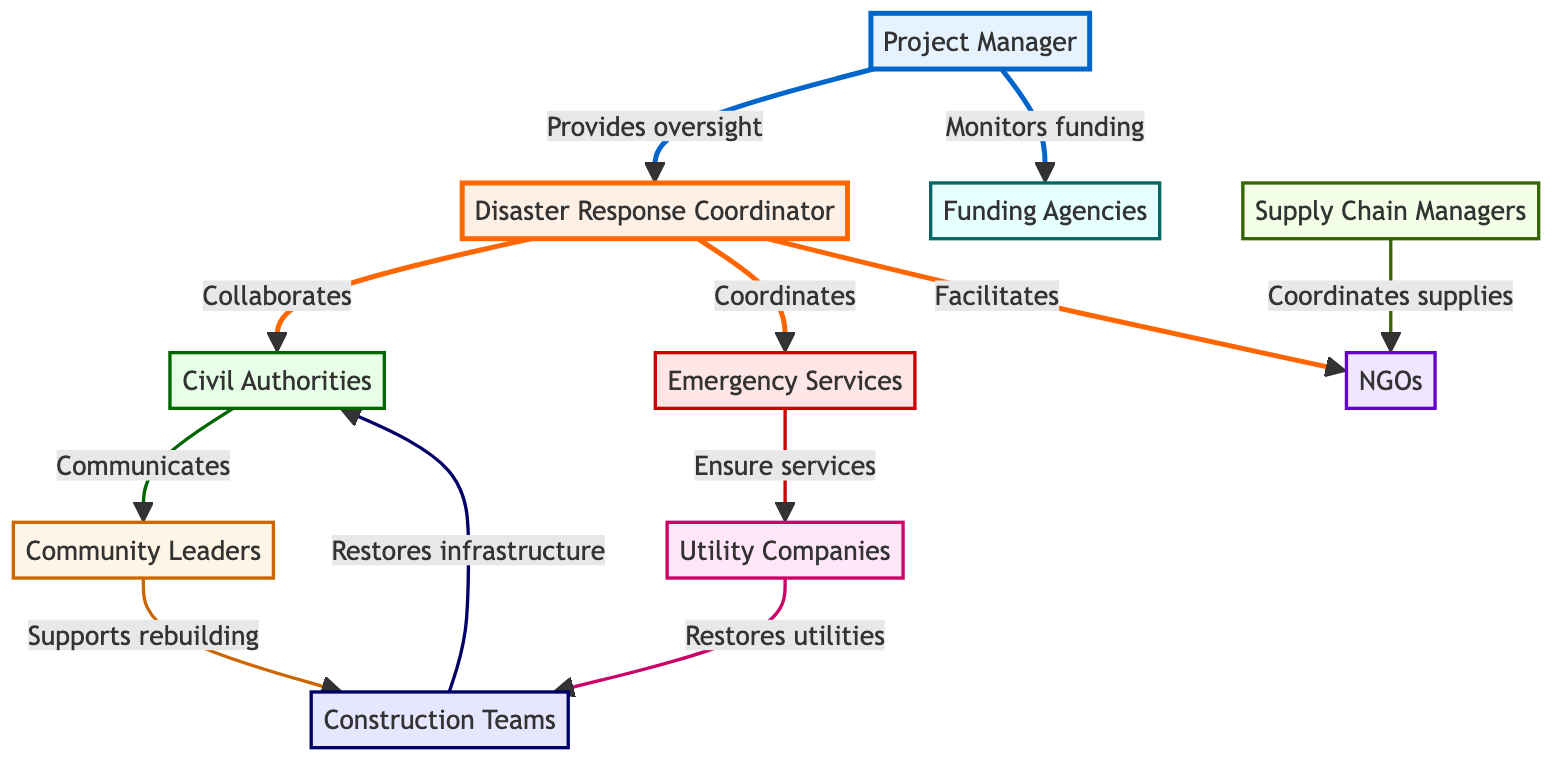What are the roles of the node with ID 4? The node with ID 4 is labeled "Emergency Services," which encompasses police, fire department, and medical teams providing immediate aid.
Answer: Emergency Services How many nodes are present in the diagram? The diagram contains a total of 10 nodes representing different stakeholders involved in post-disaster recovery.
Answer: 10 Who does the Disaster Response Coordinator coordinate with for immediate emergency response? The Disaster Response Coordinator, represented by node ID 2, coordinates with Emergency Services, represented by node ID 4, for immediate emergency response.
Answer: Emergency Services What is the relationship between the Project Manager and Funding Agencies? The Project Manager provides monitoring and reporting on funding utilization for the Funding Agencies in the diagram.
Answer: Monitors and reports on funding utilization Which node facilitates the involvement of Non-Governmental Organizations? The node that facilitates NGO involvement and aid is the Disaster Response Coordinator, represented by node ID 2, in the diagram.
Answer: Disaster Response Coordinator What role do Supply Chain Managers play in relation to NGOs? Supply Chain Managers, represented by node ID 9, coordinate the delivery of aid supplies to the Non-Governmental Organizations represented by node ID 5.
Answer: Coordinates delivery of aid supplies Which stakeholders communicate community needs and priorities? The Civil Authorities, represented by node ID 3, communicate community needs and priorities to Community Leaders, represented by node ID 6, according to the relationships in the diagram.
Answer: Civil Authorities What supports the local rebuilding efforts? The Community Leaders, represented by node ID 6, support the local rebuilding efforts that involve Construction Teams, represented by node ID 10, according to the diagram.
Answer: Community Leaders In total, how many edges are connecting the nodes? There are 11 edges connecting the various nodes, representing the relationships and interactions among the stakeholders in the recovery process.
Answer: 11 